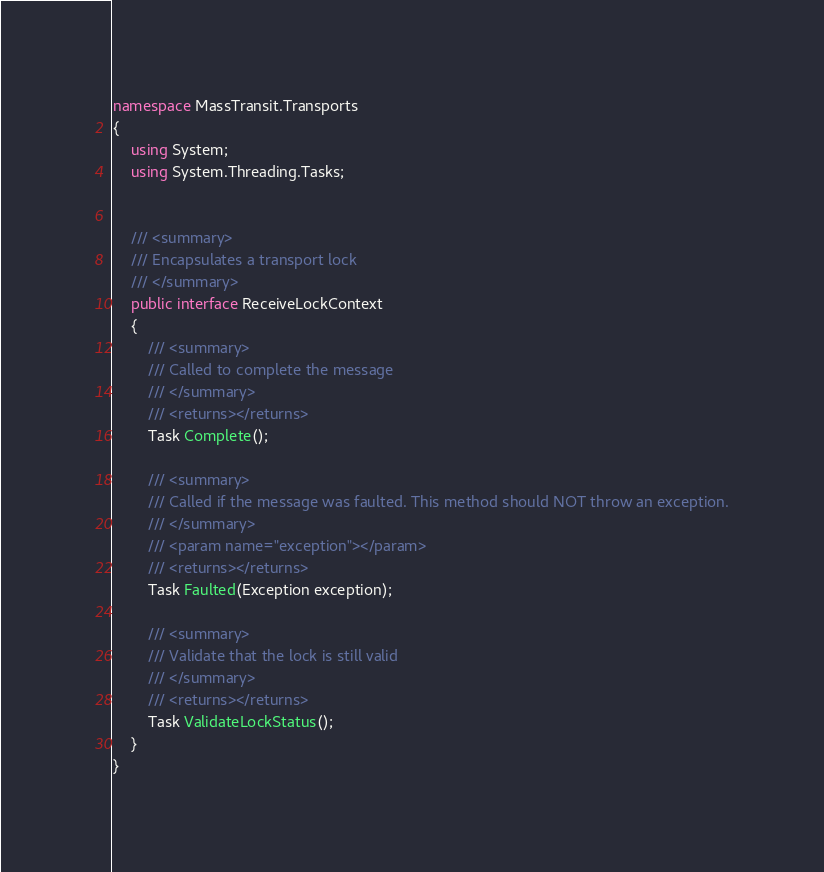Convert code to text. <code><loc_0><loc_0><loc_500><loc_500><_C#_>namespace MassTransit.Transports
{
    using System;
    using System.Threading.Tasks;


    /// <summary>
    /// Encapsulates a transport lock
    /// </summary>
    public interface ReceiveLockContext
    {
        /// <summary>
        /// Called to complete the message
        /// </summary>
        /// <returns></returns>
        Task Complete();

        /// <summary>
        /// Called if the message was faulted. This method should NOT throw an exception.
        /// </summary>
        /// <param name="exception"></param>
        /// <returns></returns>
        Task Faulted(Exception exception);

        /// <summary>
        /// Validate that the lock is still valid
        /// </summary>
        /// <returns></returns>
        Task ValidateLockStatus();
    }
}
</code> 